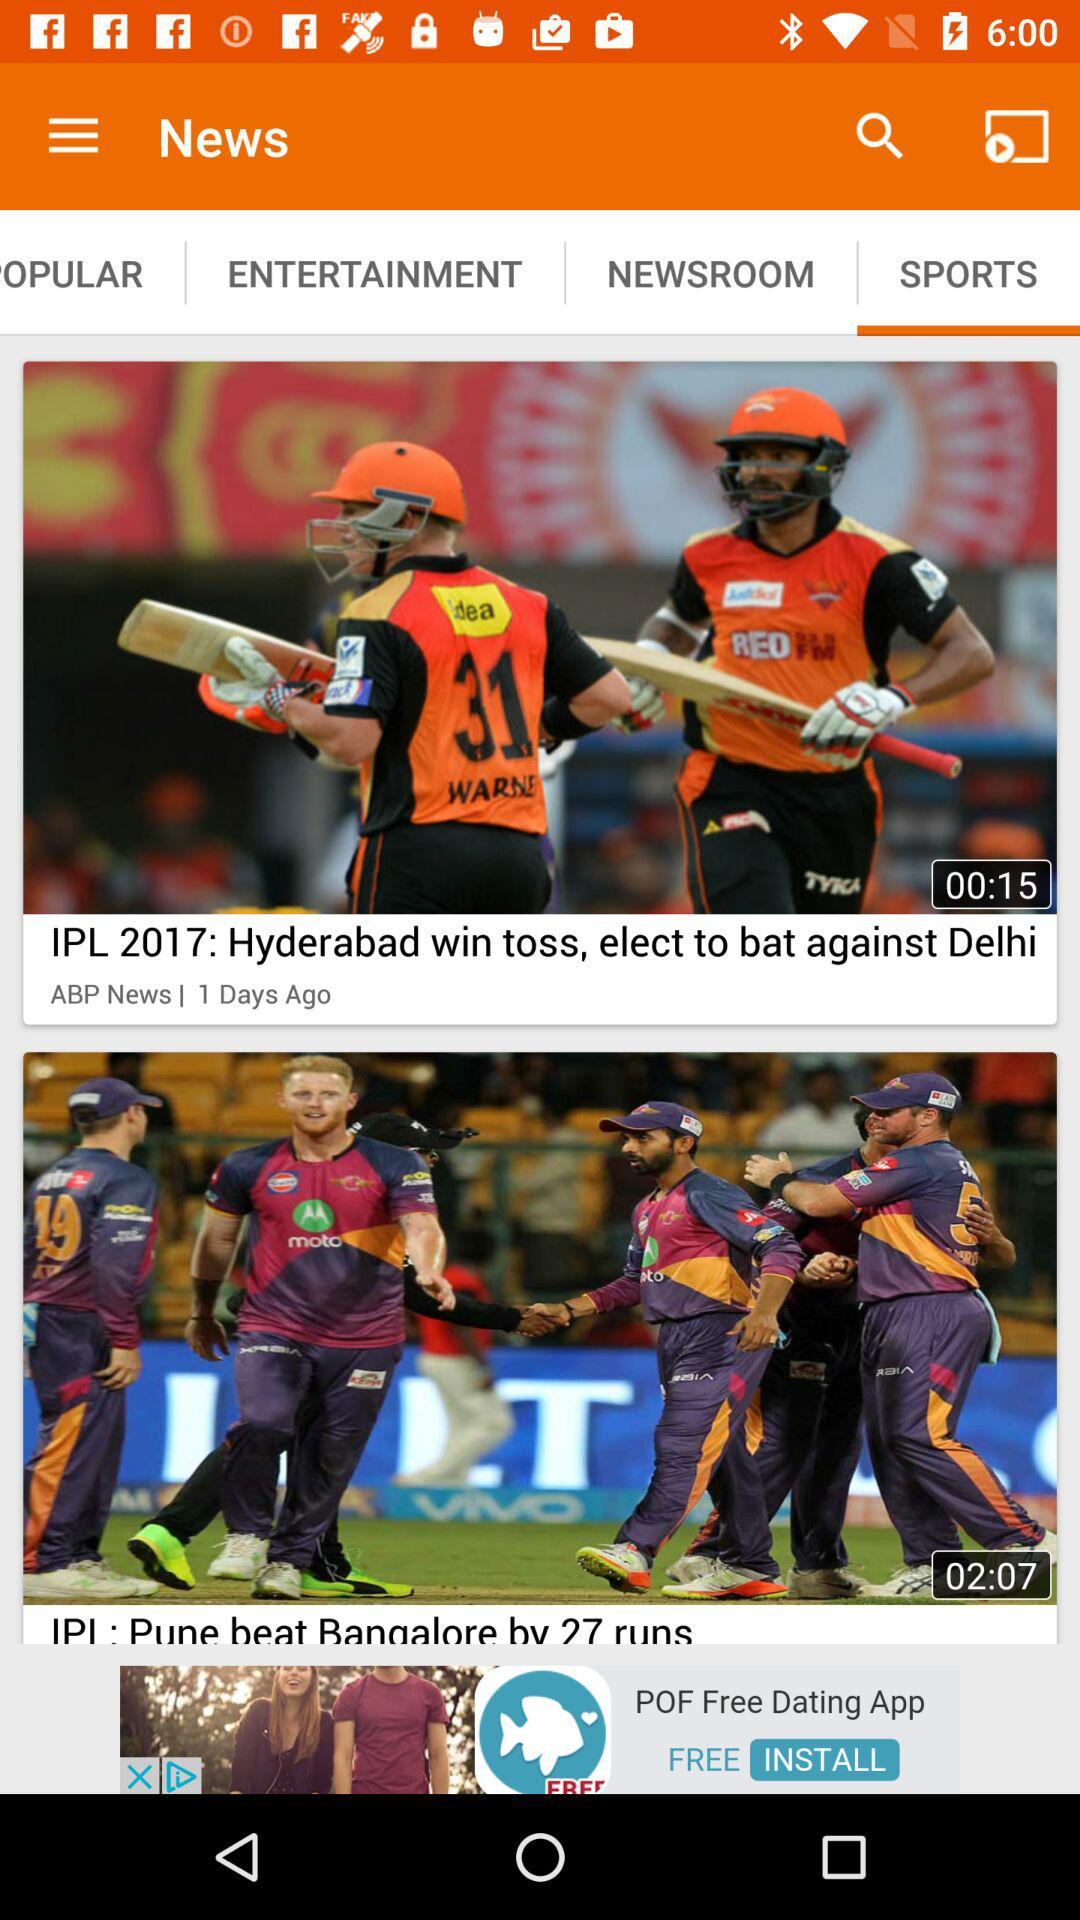How many more runs did Pune score than Bangalore?
Answer the question using a single word or phrase. 27 